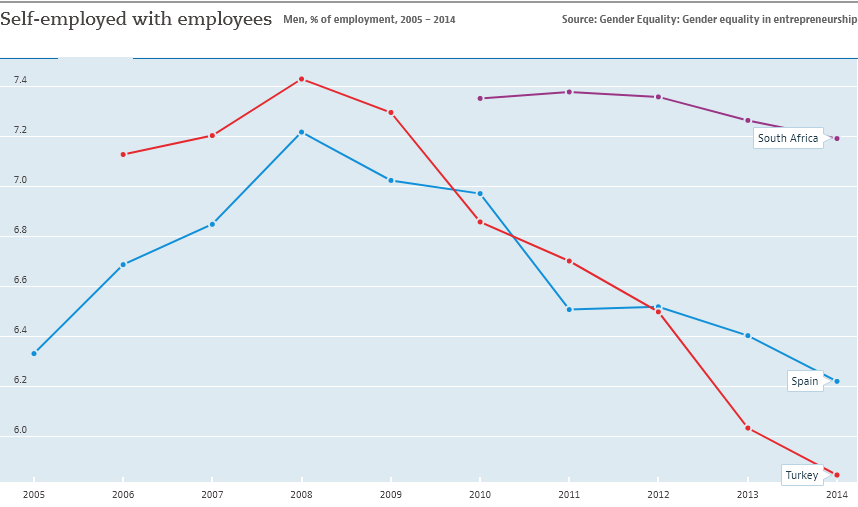Outline some significant characteristics in this image. The sum of three countries is greatest in 2010. The graph displays 3 countries. 